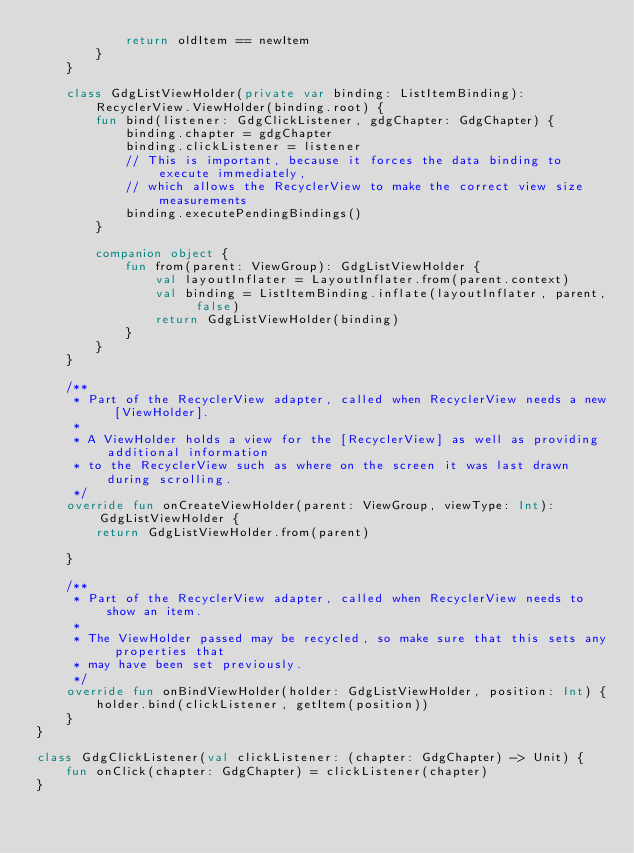Convert code to text. <code><loc_0><loc_0><loc_500><loc_500><_Kotlin_>            return oldItem == newItem
        }
    }

    class GdgListViewHolder(private var binding: ListItemBinding):
        RecyclerView.ViewHolder(binding.root) {
        fun bind(listener: GdgClickListener, gdgChapter: GdgChapter) {
            binding.chapter = gdgChapter
            binding.clickListener = listener
            // This is important, because it forces the data binding to execute immediately,
            // which allows the RecyclerView to make the correct view size measurements
            binding.executePendingBindings()
        }

        companion object {
            fun from(parent: ViewGroup): GdgListViewHolder {
                val layoutInflater = LayoutInflater.from(parent.context)
                val binding = ListItemBinding.inflate(layoutInflater, parent, false)
                return GdgListViewHolder(binding)
            }
        }
    }

    /**
     * Part of the RecyclerView adapter, called when RecyclerView needs a new [ViewHolder].
     *
     * A ViewHolder holds a view for the [RecyclerView] as well as providing additional information
     * to the RecyclerView such as where on the screen it was last drawn during scrolling.
     */
    override fun onCreateViewHolder(parent: ViewGroup, viewType: Int): GdgListViewHolder {
        return GdgListViewHolder.from(parent)

    }

    /**
     * Part of the RecyclerView adapter, called when RecyclerView needs to show an item.
     *
     * The ViewHolder passed may be recycled, so make sure that this sets any properties that
     * may have been set previously.
     */
    override fun onBindViewHolder(holder: GdgListViewHolder, position: Int) {
        holder.bind(clickListener, getItem(position))
    }
}

class GdgClickListener(val clickListener: (chapter: GdgChapter) -> Unit) {
    fun onClick(chapter: GdgChapter) = clickListener(chapter)
}
</code> 